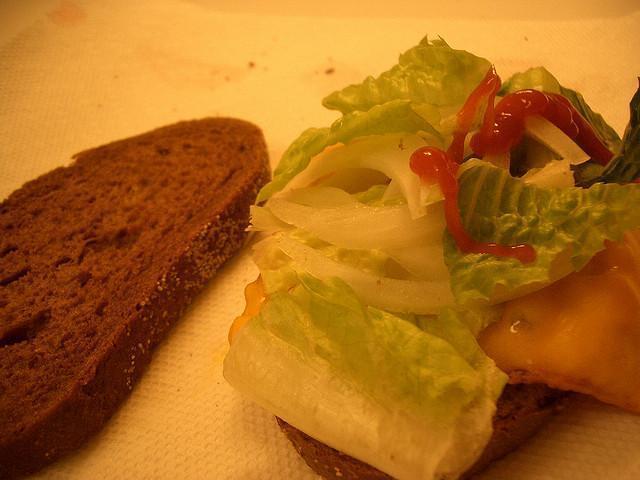How many sandwiches are visible?
Give a very brief answer. 2. 